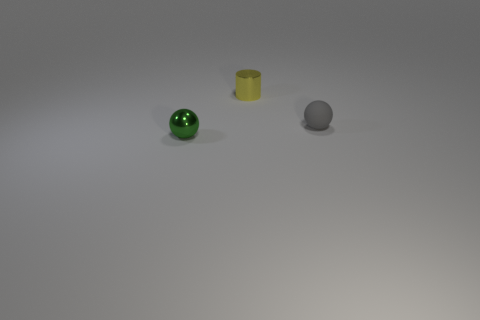How many objects are there in the image and can you describe their colors? There are three objects in the image. From left to right, the first is a shiny green sphere, the second is a matte yellow cylinder, and the third is a gray sphere with a slightly rough texture. 